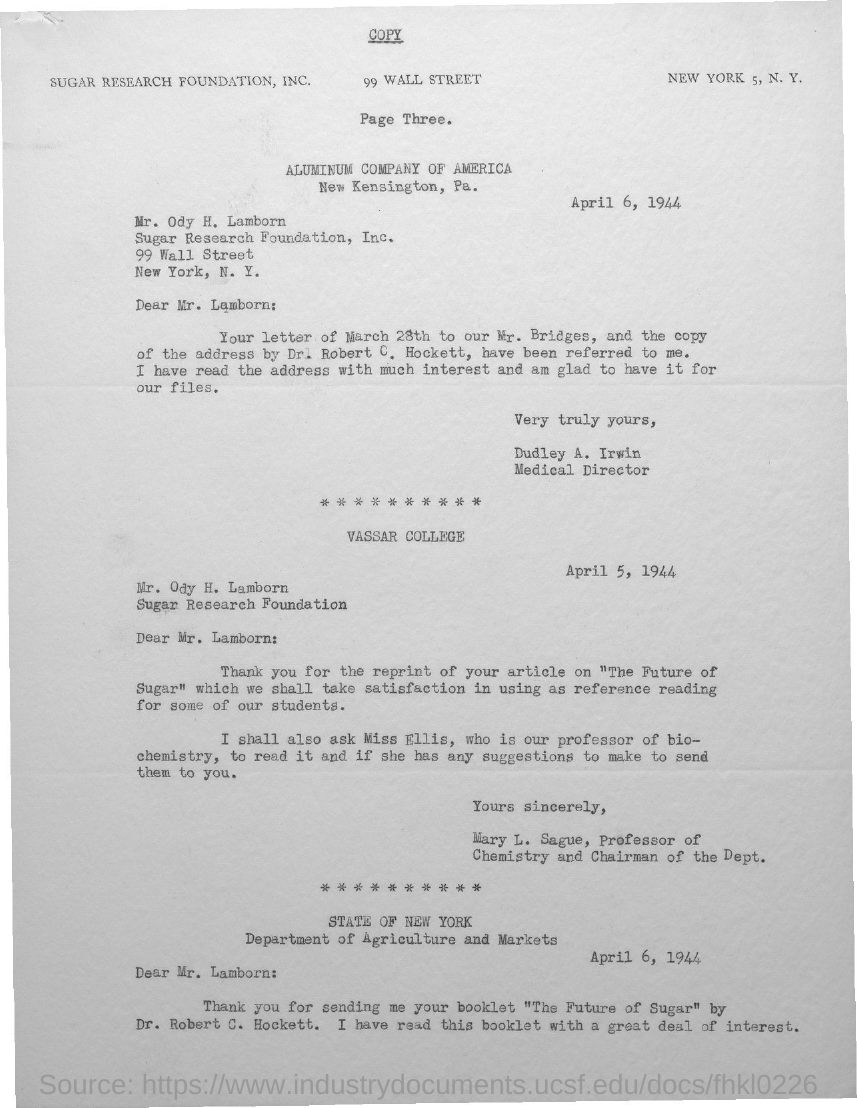Draw attention to some important aspects in this diagram. The addressee of the first letter in this document is identified as Ody H. Lamborn. Dudley A. Irwin's designation is Medical Director. Mary L. Sague holds the designation of Professor of Chemistry and is the Chairman of the Department. The sender of the first letter in this document is Dudley A. Irwin. The date mentioned in the first letter of this document is April 6, 1944. 